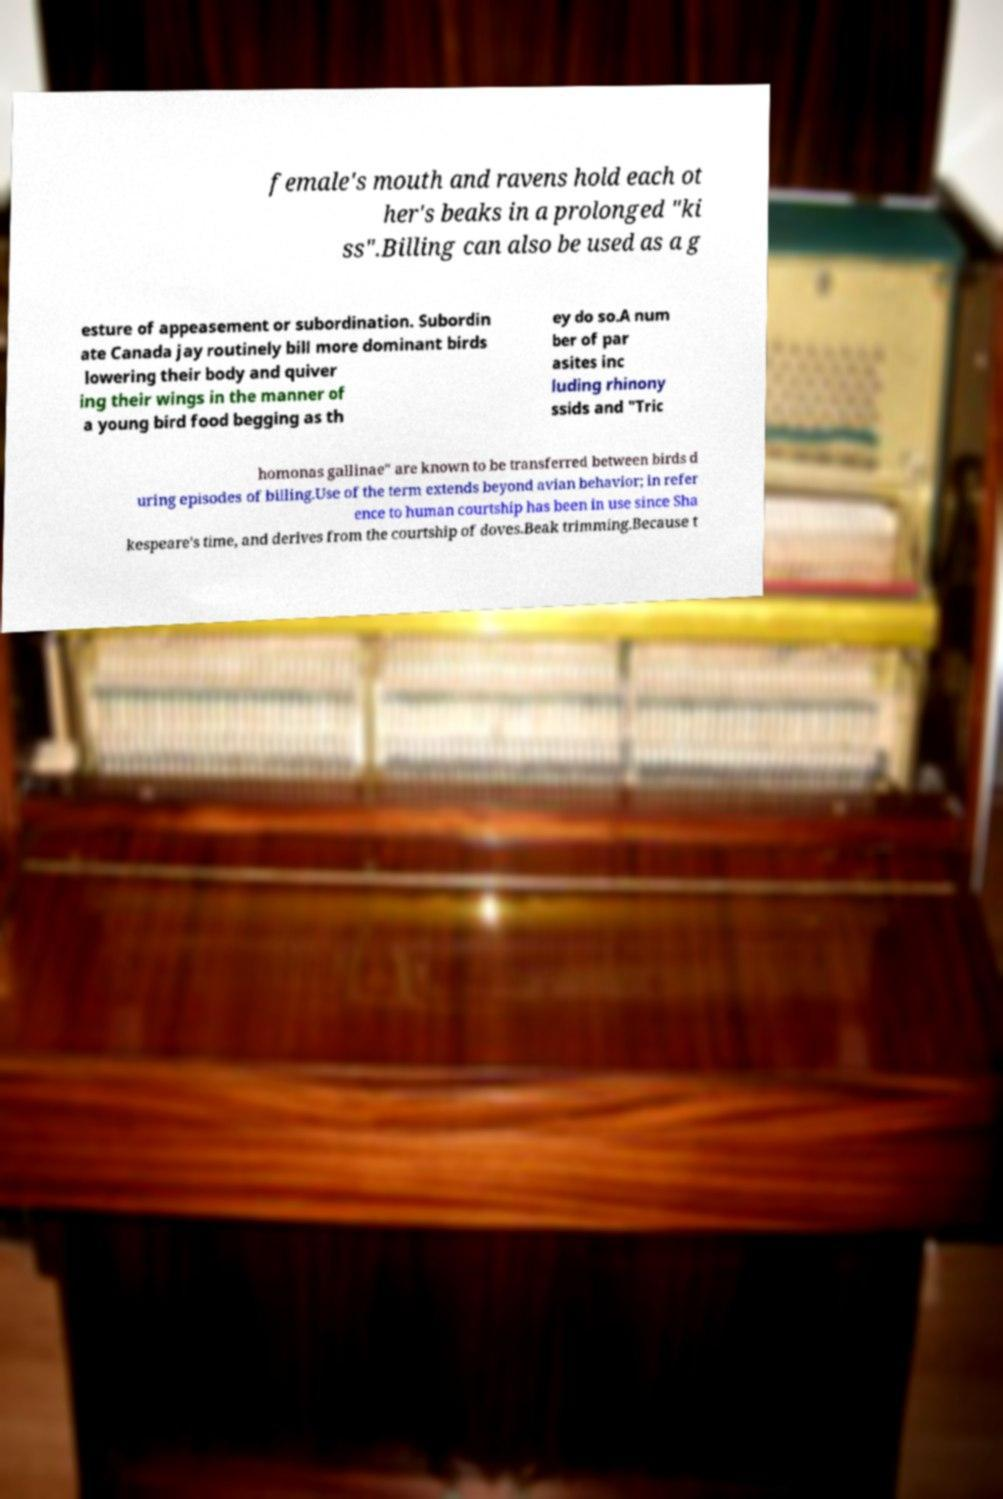Could you assist in decoding the text presented in this image and type it out clearly? female's mouth and ravens hold each ot her's beaks in a prolonged "ki ss".Billing can also be used as a g esture of appeasement or subordination. Subordin ate Canada jay routinely bill more dominant birds lowering their body and quiver ing their wings in the manner of a young bird food begging as th ey do so.A num ber of par asites inc luding rhinony ssids and "Tric homonas gallinae" are known to be transferred between birds d uring episodes of billing.Use of the term extends beyond avian behavior; in refer ence to human courtship has been in use since Sha kespeare's time, and derives from the courtship of doves.Beak trimming.Because t 